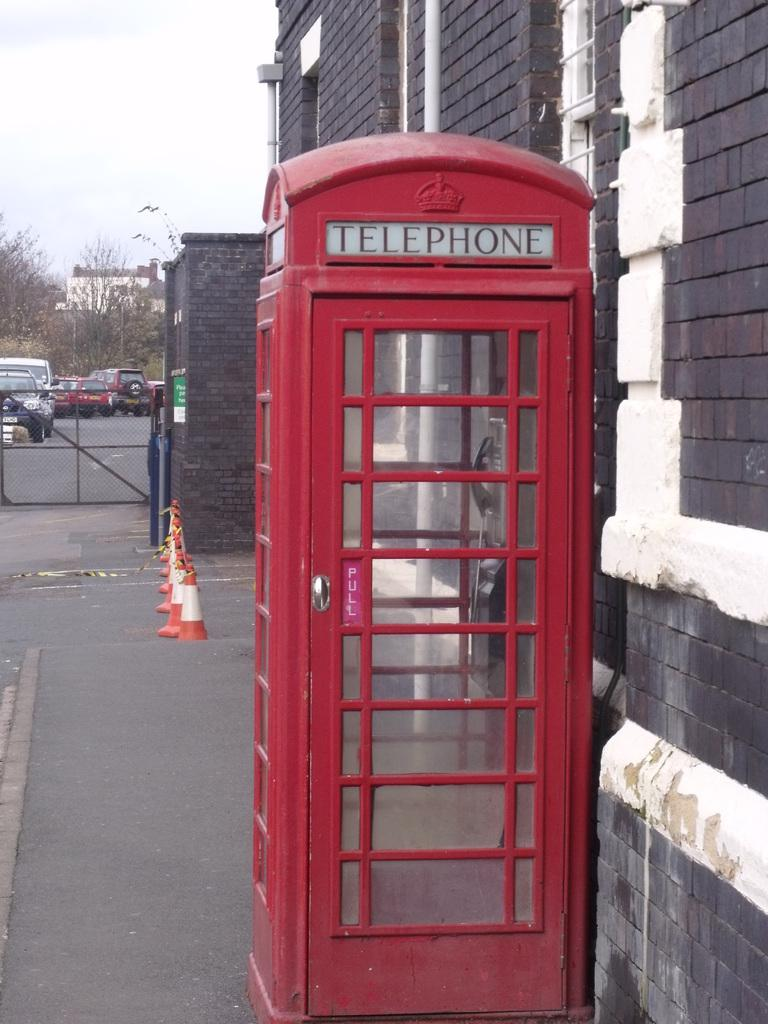<image>
Present a compact description of the photo's key features. An old British style telephone booth on the side of a building. 